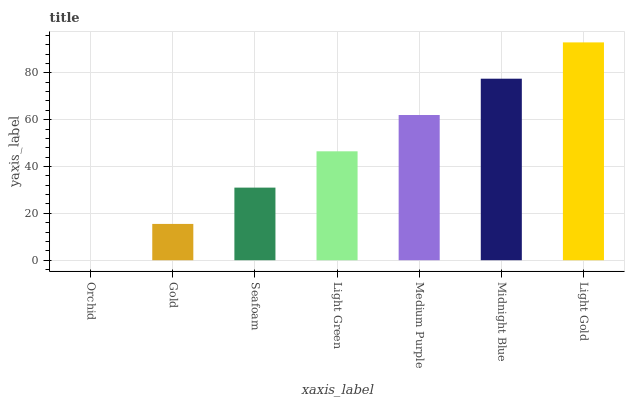Is Orchid the minimum?
Answer yes or no. Yes. Is Light Gold the maximum?
Answer yes or no. Yes. Is Gold the minimum?
Answer yes or no. No. Is Gold the maximum?
Answer yes or no. No. Is Gold greater than Orchid?
Answer yes or no. Yes. Is Orchid less than Gold?
Answer yes or no. Yes. Is Orchid greater than Gold?
Answer yes or no. No. Is Gold less than Orchid?
Answer yes or no. No. Is Light Green the high median?
Answer yes or no. Yes. Is Light Green the low median?
Answer yes or no. Yes. Is Medium Purple the high median?
Answer yes or no. No. Is Orchid the low median?
Answer yes or no. No. 